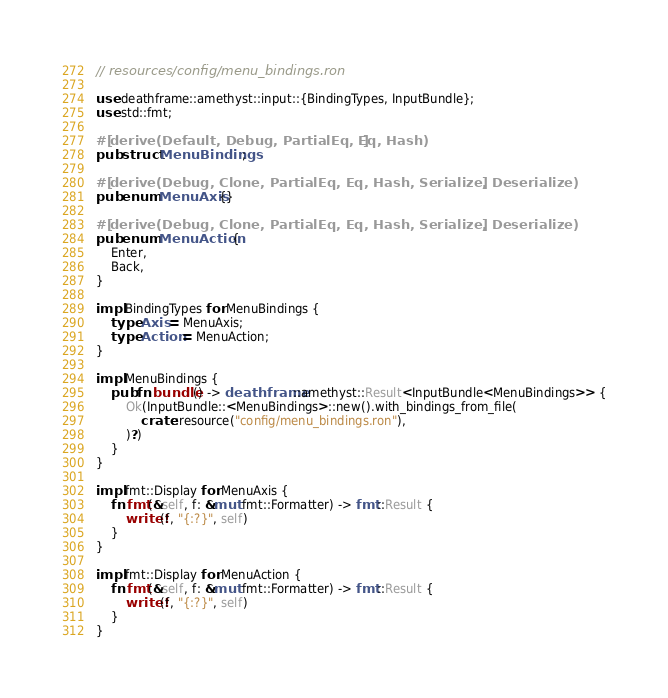Convert code to text. <code><loc_0><loc_0><loc_500><loc_500><_Rust_>// resources/config/menu_bindings.ron

use deathframe::amethyst::input::{BindingTypes, InputBundle};
use std::fmt;

#[derive(Default, Debug, PartialEq, Eq, Hash)]
pub struct MenuBindings;

#[derive(Debug, Clone, PartialEq, Eq, Hash, Serialize, Deserialize)]
pub enum MenuAxis {}

#[derive(Debug, Clone, PartialEq, Eq, Hash, Serialize, Deserialize)]
pub enum MenuAction {
    Enter,
    Back,
}

impl BindingTypes for MenuBindings {
    type Axis = MenuAxis;
    type Action = MenuAction;
}

impl MenuBindings {
    pub fn bundle() -> deathframe::amethyst::Result<InputBundle<MenuBindings>> {
        Ok(InputBundle::<MenuBindings>::new().with_bindings_from_file(
            crate::resource("config/menu_bindings.ron"),
        )?)
    }
}

impl fmt::Display for MenuAxis {
    fn fmt(&self, f: &mut fmt::Formatter) -> fmt::Result {
        write!(f, "{:?}", self)
    }
}

impl fmt::Display for MenuAction {
    fn fmt(&self, f: &mut fmt::Formatter) -> fmt::Result {
        write!(f, "{:?}", self)
    }
}
</code> 